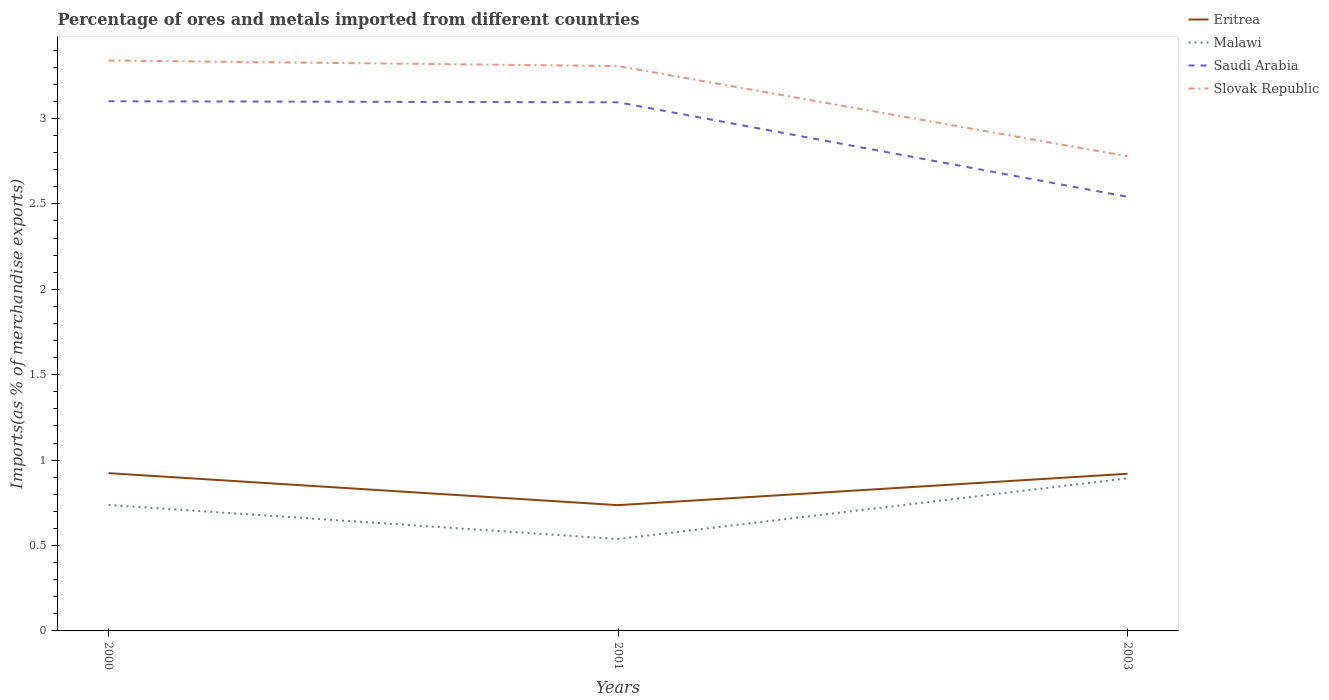Is the number of lines equal to the number of legend labels?
Your answer should be compact. Yes. Across all years, what is the maximum percentage of imports to different countries in Malawi?
Keep it short and to the point. 0.54. What is the total percentage of imports to different countries in Saudi Arabia in the graph?
Offer a terse response. 0.01. What is the difference between the highest and the second highest percentage of imports to different countries in Slovak Republic?
Provide a short and direct response. 0.56. What is the difference between two consecutive major ticks on the Y-axis?
Offer a terse response. 0.5. Where does the legend appear in the graph?
Provide a short and direct response. Top right. How are the legend labels stacked?
Give a very brief answer. Vertical. What is the title of the graph?
Provide a succinct answer. Percentage of ores and metals imported from different countries. Does "Iceland" appear as one of the legend labels in the graph?
Keep it short and to the point. No. What is the label or title of the X-axis?
Provide a short and direct response. Years. What is the label or title of the Y-axis?
Your answer should be very brief. Imports(as % of merchandise exports). What is the Imports(as % of merchandise exports) of Eritrea in 2000?
Provide a short and direct response. 0.92. What is the Imports(as % of merchandise exports) of Malawi in 2000?
Offer a terse response. 0.74. What is the Imports(as % of merchandise exports) of Saudi Arabia in 2000?
Your response must be concise. 3.1. What is the Imports(as % of merchandise exports) of Slovak Republic in 2000?
Offer a terse response. 3.34. What is the Imports(as % of merchandise exports) of Eritrea in 2001?
Provide a succinct answer. 0.74. What is the Imports(as % of merchandise exports) of Malawi in 2001?
Provide a succinct answer. 0.54. What is the Imports(as % of merchandise exports) of Saudi Arabia in 2001?
Give a very brief answer. 3.09. What is the Imports(as % of merchandise exports) of Slovak Republic in 2001?
Ensure brevity in your answer.  3.31. What is the Imports(as % of merchandise exports) of Eritrea in 2003?
Ensure brevity in your answer.  0.92. What is the Imports(as % of merchandise exports) of Malawi in 2003?
Offer a very short reply. 0.89. What is the Imports(as % of merchandise exports) in Saudi Arabia in 2003?
Provide a succinct answer. 2.54. What is the Imports(as % of merchandise exports) in Slovak Republic in 2003?
Your answer should be very brief. 2.78. Across all years, what is the maximum Imports(as % of merchandise exports) in Eritrea?
Give a very brief answer. 0.92. Across all years, what is the maximum Imports(as % of merchandise exports) in Malawi?
Give a very brief answer. 0.89. Across all years, what is the maximum Imports(as % of merchandise exports) of Saudi Arabia?
Make the answer very short. 3.1. Across all years, what is the maximum Imports(as % of merchandise exports) of Slovak Republic?
Provide a succinct answer. 3.34. Across all years, what is the minimum Imports(as % of merchandise exports) in Eritrea?
Provide a short and direct response. 0.74. Across all years, what is the minimum Imports(as % of merchandise exports) of Malawi?
Provide a short and direct response. 0.54. Across all years, what is the minimum Imports(as % of merchandise exports) in Saudi Arabia?
Provide a succinct answer. 2.54. Across all years, what is the minimum Imports(as % of merchandise exports) of Slovak Republic?
Make the answer very short. 2.78. What is the total Imports(as % of merchandise exports) of Eritrea in the graph?
Offer a very short reply. 2.58. What is the total Imports(as % of merchandise exports) in Malawi in the graph?
Your response must be concise. 2.17. What is the total Imports(as % of merchandise exports) of Saudi Arabia in the graph?
Offer a terse response. 8.74. What is the total Imports(as % of merchandise exports) in Slovak Republic in the graph?
Your response must be concise. 9.42. What is the difference between the Imports(as % of merchandise exports) of Eritrea in 2000 and that in 2001?
Provide a short and direct response. 0.19. What is the difference between the Imports(as % of merchandise exports) of Malawi in 2000 and that in 2001?
Give a very brief answer. 0.2. What is the difference between the Imports(as % of merchandise exports) in Saudi Arabia in 2000 and that in 2001?
Give a very brief answer. 0.01. What is the difference between the Imports(as % of merchandise exports) of Slovak Republic in 2000 and that in 2001?
Keep it short and to the point. 0.03. What is the difference between the Imports(as % of merchandise exports) of Eritrea in 2000 and that in 2003?
Make the answer very short. 0. What is the difference between the Imports(as % of merchandise exports) in Malawi in 2000 and that in 2003?
Your response must be concise. -0.16. What is the difference between the Imports(as % of merchandise exports) of Saudi Arabia in 2000 and that in 2003?
Make the answer very short. 0.56. What is the difference between the Imports(as % of merchandise exports) in Slovak Republic in 2000 and that in 2003?
Your answer should be very brief. 0.56. What is the difference between the Imports(as % of merchandise exports) in Eritrea in 2001 and that in 2003?
Ensure brevity in your answer.  -0.18. What is the difference between the Imports(as % of merchandise exports) in Malawi in 2001 and that in 2003?
Ensure brevity in your answer.  -0.36. What is the difference between the Imports(as % of merchandise exports) in Saudi Arabia in 2001 and that in 2003?
Your response must be concise. 0.55. What is the difference between the Imports(as % of merchandise exports) of Slovak Republic in 2001 and that in 2003?
Provide a short and direct response. 0.53. What is the difference between the Imports(as % of merchandise exports) in Eritrea in 2000 and the Imports(as % of merchandise exports) in Malawi in 2001?
Your answer should be very brief. 0.39. What is the difference between the Imports(as % of merchandise exports) of Eritrea in 2000 and the Imports(as % of merchandise exports) of Saudi Arabia in 2001?
Provide a succinct answer. -2.17. What is the difference between the Imports(as % of merchandise exports) in Eritrea in 2000 and the Imports(as % of merchandise exports) in Slovak Republic in 2001?
Provide a short and direct response. -2.38. What is the difference between the Imports(as % of merchandise exports) in Malawi in 2000 and the Imports(as % of merchandise exports) in Saudi Arabia in 2001?
Offer a terse response. -2.36. What is the difference between the Imports(as % of merchandise exports) in Malawi in 2000 and the Imports(as % of merchandise exports) in Slovak Republic in 2001?
Keep it short and to the point. -2.57. What is the difference between the Imports(as % of merchandise exports) of Saudi Arabia in 2000 and the Imports(as % of merchandise exports) of Slovak Republic in 2001?
Make the answer very short. -0.21. What is the difference between the Imports(as % of merchandise exports) in Eritrea in 2000 and the Imports(as % of merchandise exports) in Malawi in 2003?
Offer a terse response. 0.03. What is the difference between the Imports(as % of merchandise exports) in Eritrea in 2000 and the Imports(as % of merchandise exports) in Saudi Arabia in 2003?
Offer a very short reply. -1.62. What is the difference between the Imports(as % of merchandise exports) in Eritrea in 2000 and the Imports(as % of merchandise exports) in Slovak Republic in 2003?
Offer a very short reply. -1.85. What is the difference between the Imports(as % of merchandise exports) in Malawi in 2000 and the Imports(as % of merchandise exports) in Saudi Arabia in 2003?
Provide a short and direct response. -1.8. What is the difference between the Imports(as % of merchandise exports) in Malawi in 2000 and the Imports(as % of merchandise exports) in Slovak Republic in 2003?
Make the answer very short. -2.04. What is the difference between the Imports(as % of merchandise exports) in Saudi Arabia in 2000 and the Imports(as % of merchandise exports) in Slovak Republic in 2003?
Your answer should be very brief. 0.32. What is the difference between the Imports(as % of merchandise exports) in Eritrea in 2001 and the Imports(as % of merchandise exports) in Malawi in 2003?
Keep it short and to the point. -0.16. What is the difference between the Imports(as % of merchandise exports) in Eritrea in 2001 and the Imports(as % of merchandise exports) in Saudi Arabia in 2003?
Provide a succinct answer. -1.8. What is the difference between the Imports(as % of merchandise exports) of Eritrea in 2001 and the Imports(as % of merchandise exports) of Slovak Republic in 2003?
Make the answer very short. -2.04. What is the difference between the Imports(as % of merchandise exports) of Malawi in 2001 and the Imports(as % of merchandise exports) of Saudi Arabia in 2003?
Provide a short and direct response. -2. What is the difference between the Imports(as % of merchandise exports) in Malawi in 2001 and the Imports(as % of merchandise exports) in Slovak Republic in 2003?
Your response must be concise. -2.24. What is the difference between the Imports(as % of merchandise exports) of Saudi Arabia in 2001 and the Imports(as % of merchandise exports) of Slovak Republic in 2003?
Your answer should be very brief. 0.32. What is the average Imports(as % of merchandise exports) of Eritrea per year?
Keep it short and to the point. 0.86. What is the average Imports(as % of merchandise exports) in Malawi per year?
Your answer should be very brief. 0.72. What is the average Imports(as % of merchandise exports) in Saudi Arabia per year?
Keep it short and to the point. 2.91. What is the average Imports(as % of merchandise exports) in Slovak Republic per year?
Your response must be concise. 3.14. In the year 2000, what is the difference between the Imports(as % of merchandise exports) of Eritrea and Imports(as % of merchandise exports) of Malawi?
Provide a succinct answer. 0.19. In the year 2000, what is the difference between the Imports(as % of merchandise exports) in Eritrea and Imports(as % of merchandise exports) in Saudi Arabia?
Make the answer very short. -2.18. In the year 2000, what is the difference between the Imports(as % of merchandise exports) in Eritrea and Imports(as % of merchandise exports) in Slovak Republic?
Offer a very short reply. -2.42. In the year 2000, what is the difference between the Imports(as % of merchandise exports) of Malawi and Imports(as % of merchandise exports) of Saudi Arabia?
Your response must be concise. -2.36. In the year 2000, what is the difference between the Imports(as % of merchandise exports) of Malawi and Imports(as % of merchandise exports) of Slovak Republic?
Make the answer very short. -2.6. In the year 2000, what is the difference between the Imports(as % of merchandise exports) in Saudi Arabia and Imports(as % of merchandise exports) in Slovak Republic?
Offer a very short reply. -0.24. In the year 2001, what is the difference between the Imports(as % of merchandise exports) of Eritrea and Imports(as % of merchandise exports) of Malawi?
Your answer should be very brief. 0.2. In the year 2001, what is the difference between the Imports(as % of merchandise exports) in Eritrea and Imports(as % of merchandise exports) in Saudi Arabia?
Keep it short and to the point. -2.36. In the year 2001, what is the difference between the Imports(as % of merchandise exports) in Eritrea and Imports(as % of merchandise exports) in Slovak Republic?
Offer a terse response. -2.57. In the year 2001, what is the difference between the Imports(as % of merchandise exports) in Malawi and Imports(as % of merchandise exports) in Saudi Arabia?
Your response must be concise. -2.56. In the year 2001, what is the difference between the Imports(as % of merchandise exports) in Malawi and Imports(as % of merchandise exports) in Slovak Republic?
Keep it short and to the point. -2.77. In the year 2001, what is the difference between the Imports(as % of merchandise exports) in Saudi Arabia and Imports(as % of merchandise exports) in Slovak Republic?
Your answer should be compact. -0.21. In the year 2003, what is the difference between the Imports(as % of merchandise exports) of Eritrea and Imports(as % of merchandise exports) of Malawi?
Offer a very short reply. 0.03. In the year 2003, what is the difference between the Imports(as % of merchandise exports) of Eritrea and Imports(as % of merchandise exports) of Saudi Arabia?
Keep it short and to the point. -1.62. In the year 2003, what is the difference between the Imports(as % of merchandise exports) of Eritrea and Imports(as % of merchandise exports) of Slovak Republic?
Make the answer very short. -1.86. In the year 2003, what is the difference between the Imports(as % of merchandise exports) in Malawi and Imports(as % of merchandise exports) in Saudi Arabia?
Ensure brevity in your answer.  -1.65. In the year 2003, what is the difference between the Imports(as % of merchandise exports) of Malawi and Imports(as % of merchandise exports) of Slovak Republic?
Offer a very short reply. -1.89. In the year 2003, what is the difference between the Imports(as % of merchandise exports) of Saudi Arabia and Imports(as % of merchandise exports) of Slovak Republic?
Keep it short and to the point. -0.24. What is the ratio of the Imports(as % of merchandise exports) in Eritrea in 2000 to that in 2001?
Ensure brevity in your answer.  1.25. What is the ratio of the Imports(as % of merchandise exports) in Malawi in 2000 to that in 2001?
Provide a succinct answer. 1.37. What is the ratio of the Imports(as % of merchandise exports) of Slovak Republic in 2000 to that in 2001?
Your answer should be very brief. 1.01. What is the ratio of the Imports(as % of merchandise exports) of Malawi in 2000 to that in 2003?
Provide a succinct answer. 0.83. What is the ratio of the Imports(as % of merchandise exports) of Saudi Arabia in 2000 to that in 2003?
Make the answer very short. 1.22. What is the ratio of the Imports(as % of merchandise exports) in Slovak Republic in 2000 to that in 2003?
Provide a succinct answer. 1.2. What is the ratio of the Imports(as % of merchandise exports) in Eritrea in 2001 to that in 2003?
Offer a terse response. 0.8. What is the ratio of the Imports(as % of merchandise exports) of Malawi in 2001 to that in 2003?
Offer a terse response. 0.6. What is the ratio of the Imports(as % of merchandise exports) in Saudi Arabia in 2001 to that in 2003?
Give a very brief answer. 1.22. What is the ratio of the Imports(as % of merchandise exports) of Slovak Republic in 2001 to that in 2003?
Provide a short and direct response. 1.19. What is the difference between the highest and the second highest Imports(as % of merchandise exports) of Eritrea?
Offer a very short reply. 0. What is the difference between the highest and the second highest Imports(as % of merchandise exports) in Malawi?
Offer a terse response. 0.16. What is the difference between the highest and the second highest Imports(as % of merchandise exports) of Saudi Arabia?
Keep it short and to the point. 0.01. What is the difference between the highest and the second highest Imports(as % of merchandise exports) in Slovak Republic?
Give a very brief answer. 0.03. What is the difference between the highest and the lowest Imports(as % of merchandise exports) in Eritrea?
Provide a succinct answer. 0.19. What is the difference between the highest and the lowest Imports(as % of merchandise exports) of Malawi?
Your answer should be very brief. 0.36. What is the difference between the highest and the lowest Imports(as % of merchandise exports) in Saudi Arabia?
Your answer should be very brief. 0.56. What is the difference between the highest and the lowest Imports(as % of merchandise exports) in Slovak Republic?
Your answer should be very brief. 0.56. 